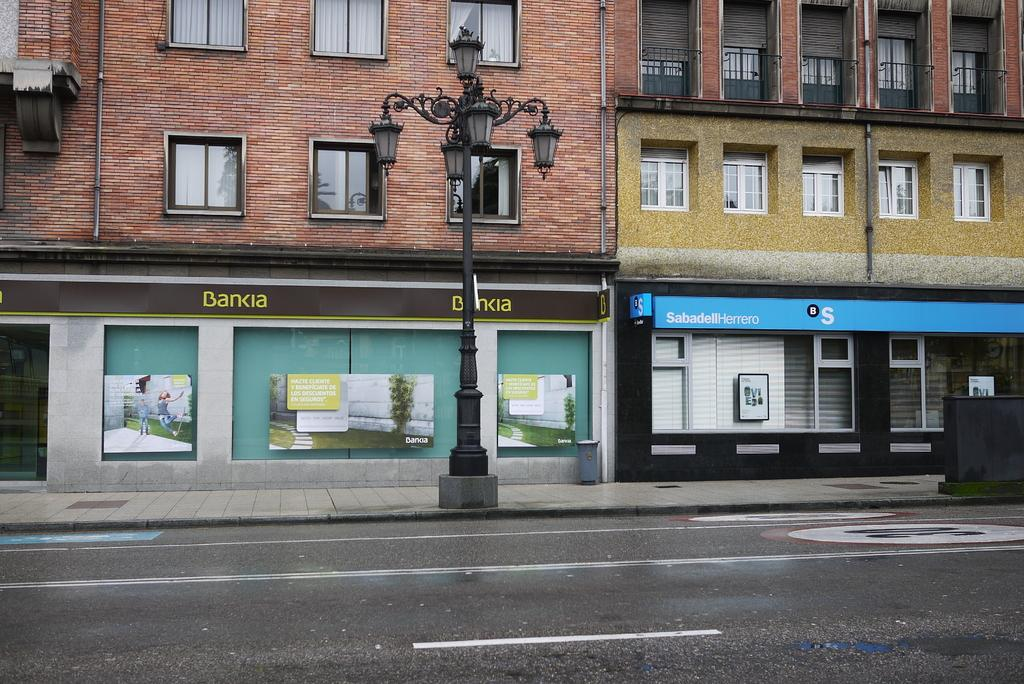What type of structures can be seen in the image? There are buildings in the image. What feature is common to many of the buildings in the image? There are windows in the image. What infrastructure elements are present in the image? There are pipelines, street poles, and street lights in the image. What type of establishments can be found in the image? There are stores in the image. What is the primary mode of transportation in the image? There is a road in the image, which suggests that vehicles are the primary mode of transportation. What type of apparel is being sold in the stores in the image? The provided facts do not mention any specific apparel being sold in the stores, so we cannot answer this question definitively. How many beds can be seen in the image? There are no beds present in the image. 